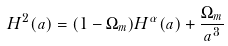<formula> <loc_0><loc_0><loc_500><loc_500>H ^ { 2 } ( a ) = ( 1 - \Omega _ { m } ) H ^ { \alpha } ( a ) + \frac { \Omega _ { m } } { a ^ { 3 } }</formula> 